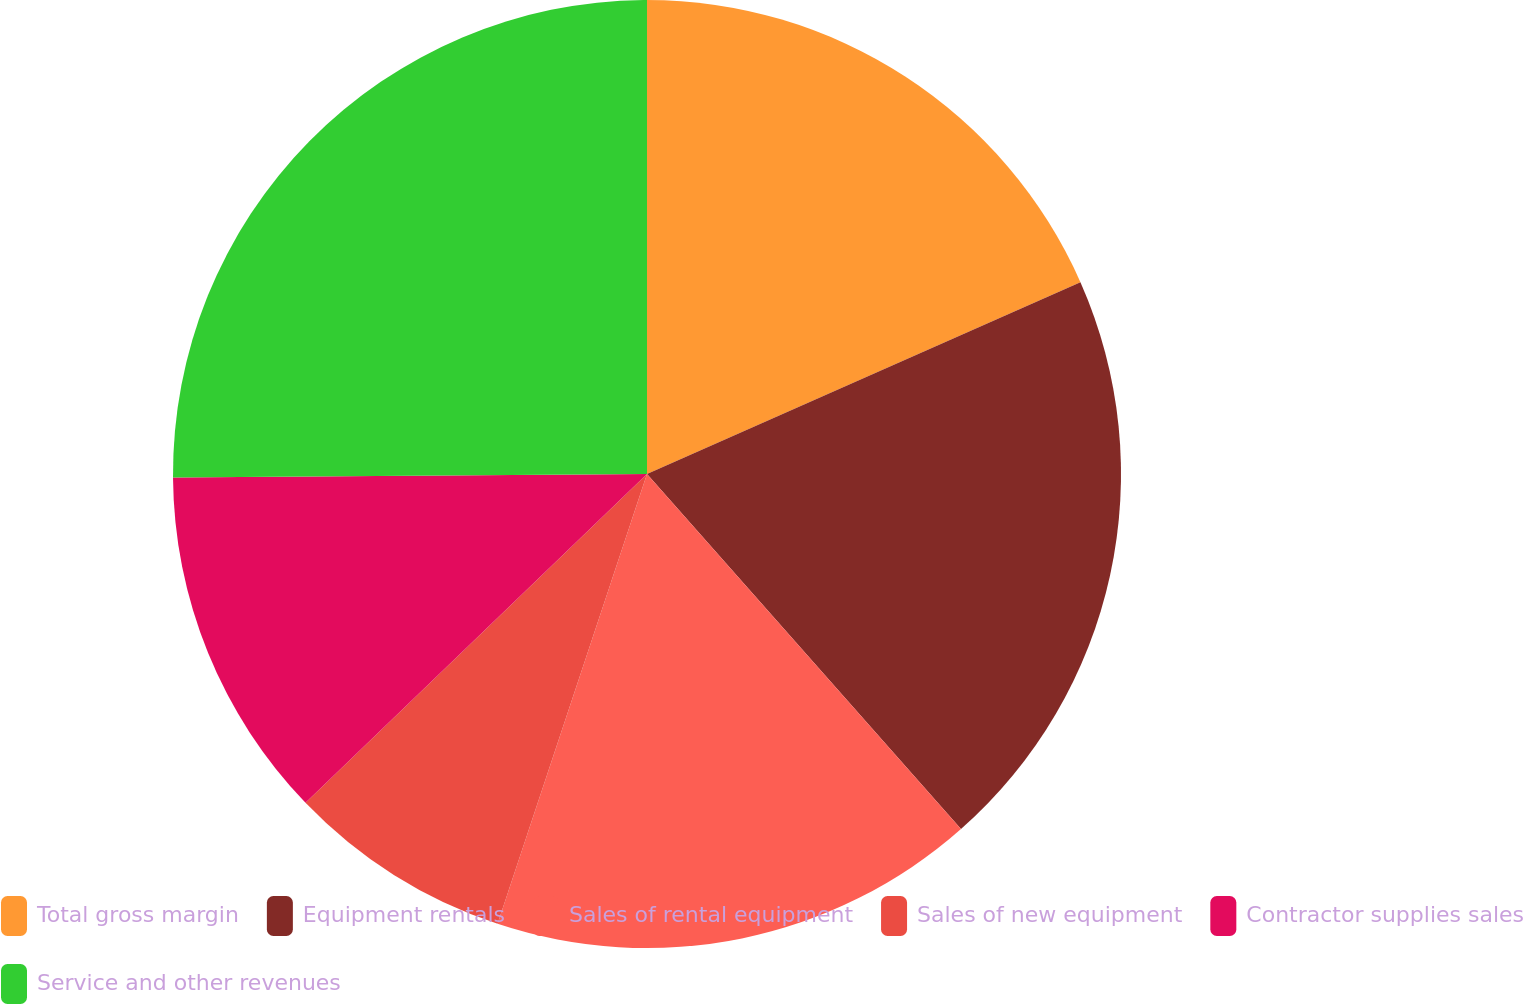Convert chart to OTSL. <chart><loc_0><loc_0><loc_500><loc_500><pie_chart><fcel>Total gross margin<fcel>Equipment rentals<fcel>Sales of rental equipment<fcel>Sales of new equipment<fcel>Contractor supplies sales<fcel>Service and other revenues<nl><fcel>18.37%<fcel>20.11%<fcel>16.63%<fcel>7.7%<fcel>12.08%<fcel>25.12%<nl></chart> 